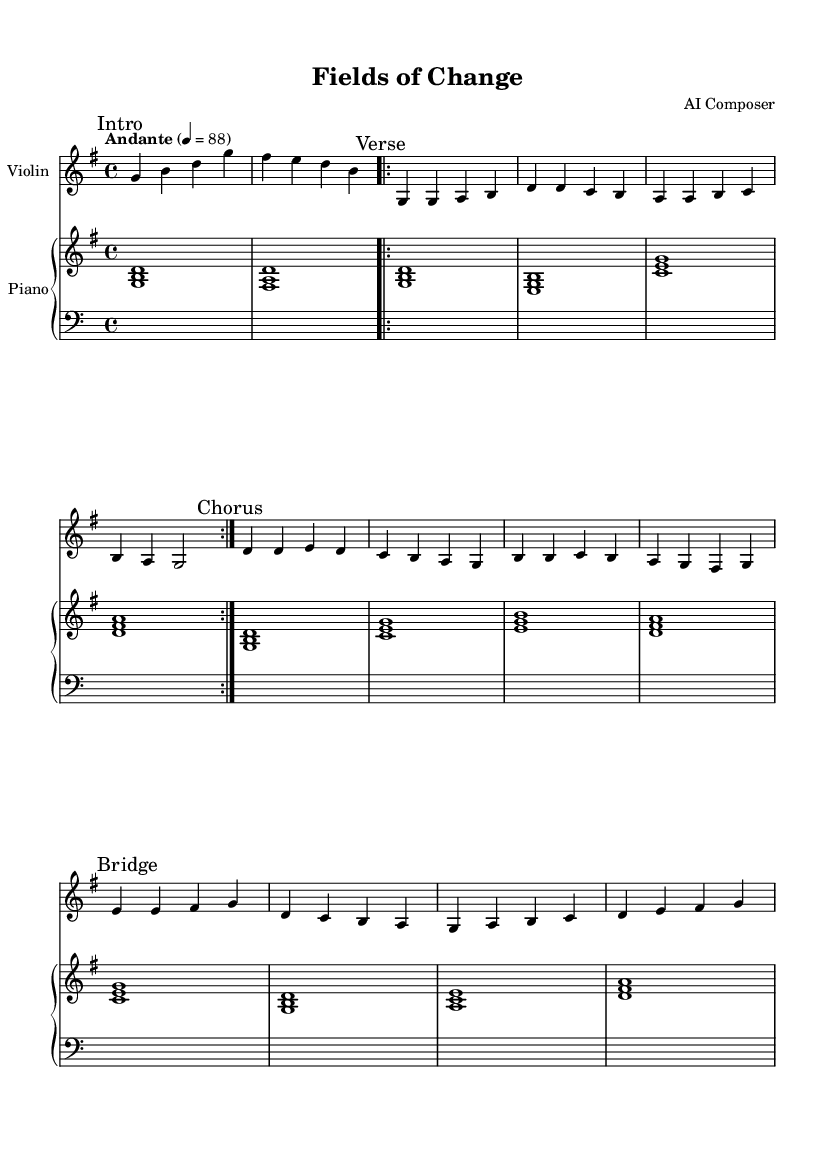What is the key signature of this music? The key signature indicated at the beginning of the score shows one sharp (F#), which identifies the key as G major.
Answer: G major What is the time signature of this music? The time signature, placed at the beginning of the score, is 4/4, meaning there are four beats per measure.
Answer: 4/4 What is the tempo marking of the piece? The tempo marking at the beginning indicates "Andante," which suggests a moderately slow pace. The numeric indication shows a metronome marking of 88 beats per minute.
Answer: Andante 4 = 88 How many sections are present in this piece? The music is divided into four distinct sections: Intro, Verse, Chorus, and Bridge. Each section is clearly marked in the score, allowing for easy identification.
Answer: Four In which section does the bridge occur? The bridge is the fourth section of the composition, coming after the Chorus section. The specific marking "Bridge" indicates its placement in the score following the Chorus.
Answer: Fourth What is the highest note played by the violin in the Chorus? In the Chorus section, the violin reaches its highest note at D (notated as d'), which is evident in the melody line of that section.
Answer: d' What is the chord progression in the Intro? The chord progression in the Intro consists of two major chords: G major (g b d) and F# minor (fis a d). This harmonic foundation sets the tone for the piece.
Answer: G major, F# minor 